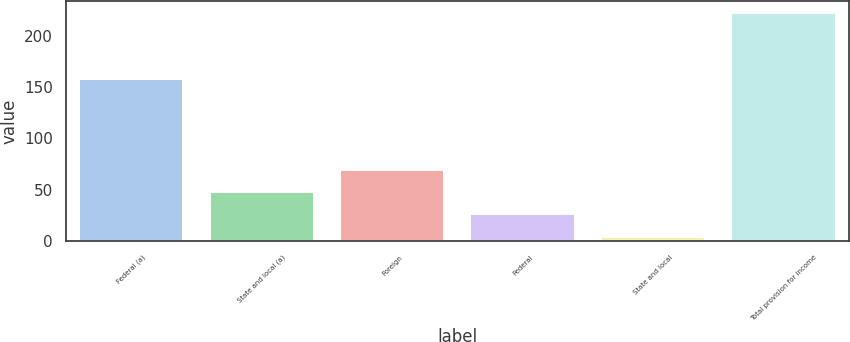<chart> <loc_0><loc_0><loc_500><loc_500><bar_chart><fcel>Federal (a)<fcel>State and local (a)<fcel>Foreign<fcel>Federal<fcel>State and local<fcel>Total provision for income<nl><fcel>157.5<fcel>47.58<fcel>69.42<fcel>25.74<fcel>3.9<fcel>222.3<nl></chart> 